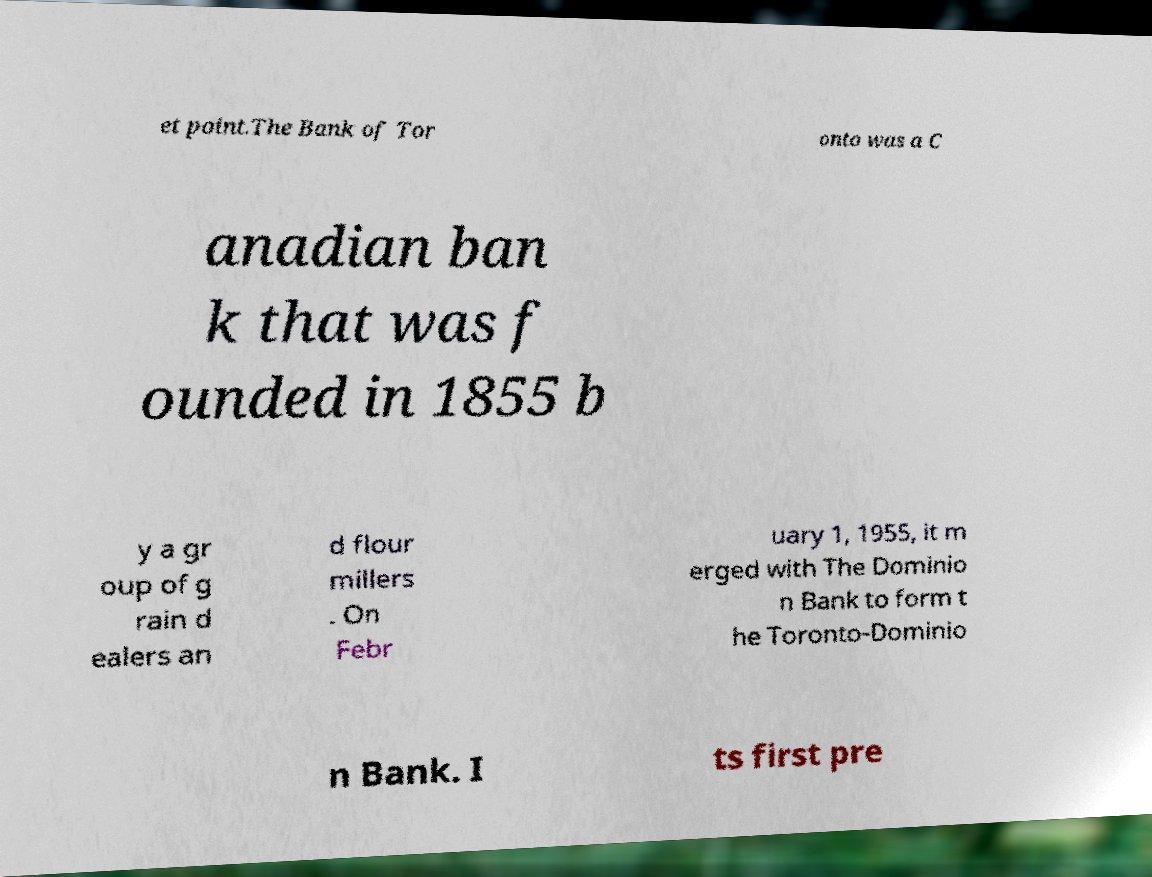There's text embedded in this image that I need extracted. Can you transcribe it verbatim? et point.The Bank of Tor onto was a C anadian ban k that was f ounded in 1855 b y a gr oup of g rain d ealers an d flour millers . On Febr uary 1, 1955, it m erged with The Dominio n Bank to form t he Toronto-Dominio n Bank. I ts first pre 